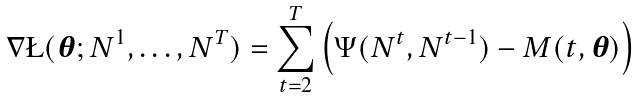<formula> <loc_0><loc_0><loc_500><loc_500>\nabla \L ( { \boldsymbol \theta } ; N ^ { 1 } , \dots , N ^ { T } ) = \sum _ { t = 2 } ^ { T } \left ( \Psi ( N ^ { t } , N ^ { t - 1 } ) - M ( t , { \boldsymbol \theta } ) \right )</formula> 